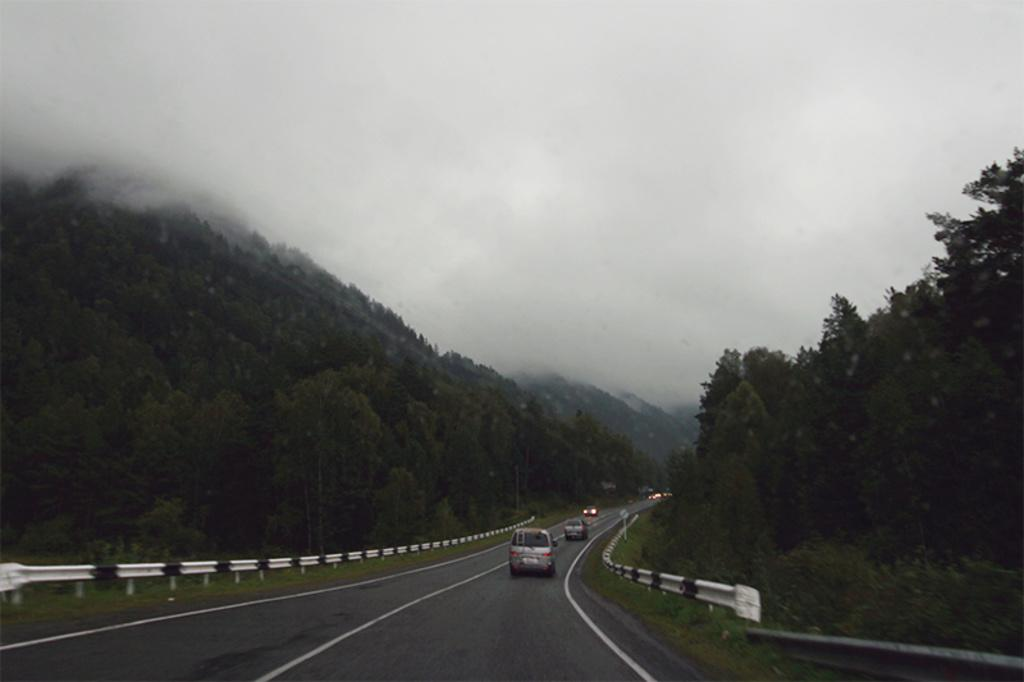Where is the image taken? The image is taken on a road. What can be seen at the bottom of the image? There is a road at the bottom of the image. What type of vegetation is present on both sides of the road? There are trees on the left and right sides of the image. What type of barrier is present on both sides of the road? There is fencing on the left and right sides of the image. What is visible at the top of the image? The sky is visible at the top of the image. What is the weather condition in the sky? There is fog in the sky. How many credit cards are visible in the image? There are no credit cards present in the image. What type of arm is visible in the image? There are no arms visible in the image. 